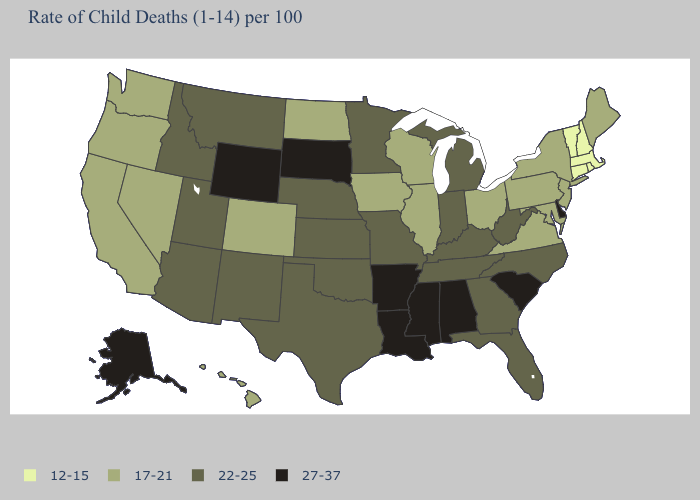Among the states that border Missouri , which have the highest value?
Keep it brief. Arkansas. What is the lowest value in the USA?
Be succinct. 12-15. What is the value of Vermont?
Write a very short answer. 12-15. What is the value of South Carolina?
Answer briefly. 27-37. Name the states that have a value in the range 22-25?
Quick response, please. Arizona, Florida, Georgia, Idaho, Indiana, Kansas, Kentucky, Michigan, Minnesota, Missouri, Montana, Nebraska, New Mexico, North Carolina, Oklahoma, Tennessee, Texas, Utah, West Virginia. Does New Hampshire have a lower value than Michigan?
Write a very short answer. Yes. Name the states that have a value in the range 27-37?
Answer briefly. Alabama, Alaska, Arkansas, Delaware, Louisiana, Mississippi, South Carolina, South Dakota, Wyoming. What is the value of West Virginia?
Concise answer only. 22-25. What is the value of West Virginia?
Concise answer only. 22-25. Which states hav the highest value in the West?
Give a very brief answer. Alaska, Wyoming. Does the first symbol in the legend represent the smallest category?
Quick response, please. Yes. What is the highest value in states that border Illinois?
Answer briefly. 22-25. Does Washington have the lowest value in the West?
Write a very short answer. Yes. Does the first symbol in the legend represent the smallest category?
Quick response, please. Yes. Which states hav the highest value in the West?
Short answer required. Alaska, Wyoming. 